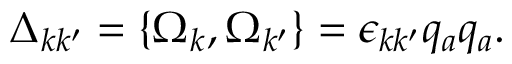<formula> <loc_0><loc_0><loc_500><loc_500>\Delta _ { k k ^ { \prime } } = \{ \Omega _ { k } , \Omega _ { k ^ { \prime } } \} = \epsilon _ { k k ^ { \prime } } q _ { a } q _ { a } .</formula> 